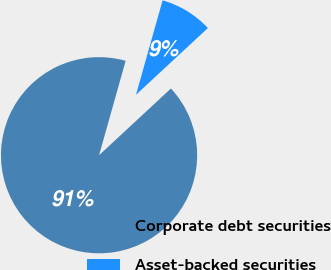Convert chart to OTSL. <chart><loc_0><loc_0><loc_500><loc_500><pie_chart><fcel>Corporate debt securities<fcel>Asset-backed securities<nl><fcel>91.28%<fcel>8.72%<nl></chart> 